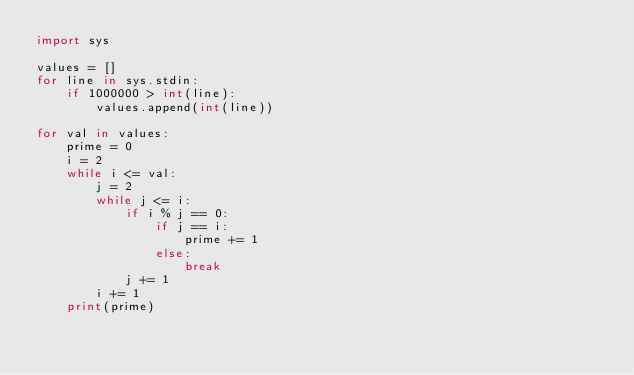Convert code to text. <code><loc_0><loc_0><loc_500><loc_500><_Python_>import sys

values = []
for line in sys.stdin:
    if 1000000 > int(line):
        values.append(int(line))

for val in values:
    prime = 0
    i = 2
    while i <= val:
        j = 2
        while j <= i:
            if i % j == 0:
                if j == i:
                    prime += 1
                else:
                    break
            j += 1
        i += 1
    print(prime)</code> 